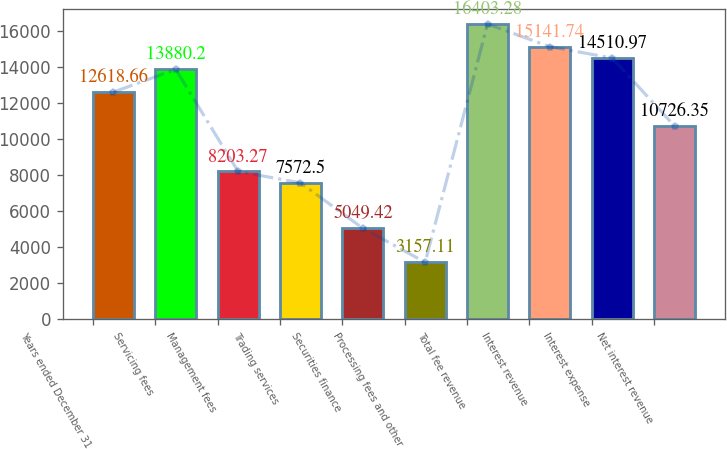Convert chart. <chart><loc_0><loc_0><loc_500><loc_500><bar_chart><fcel>Years ended December 31<fcel>Servicing fees<fcel>Management fees<fcel>Trading services<fcel>Securities finance<fcel>Processing fees and other<fcel>Total fee revenue<fcel>Interest revenue<fcel>Interest expense<fcel>Net interest revenue<nl><fcel>12618.7<fcel>13880.2<fcel>8203.27<fcel>7572.5<fcel>5049.42<fcel>3157.11<fcel>16403.3<fcel>15141.7<fcel>14511<fcel>10726.4<nl></chart> 